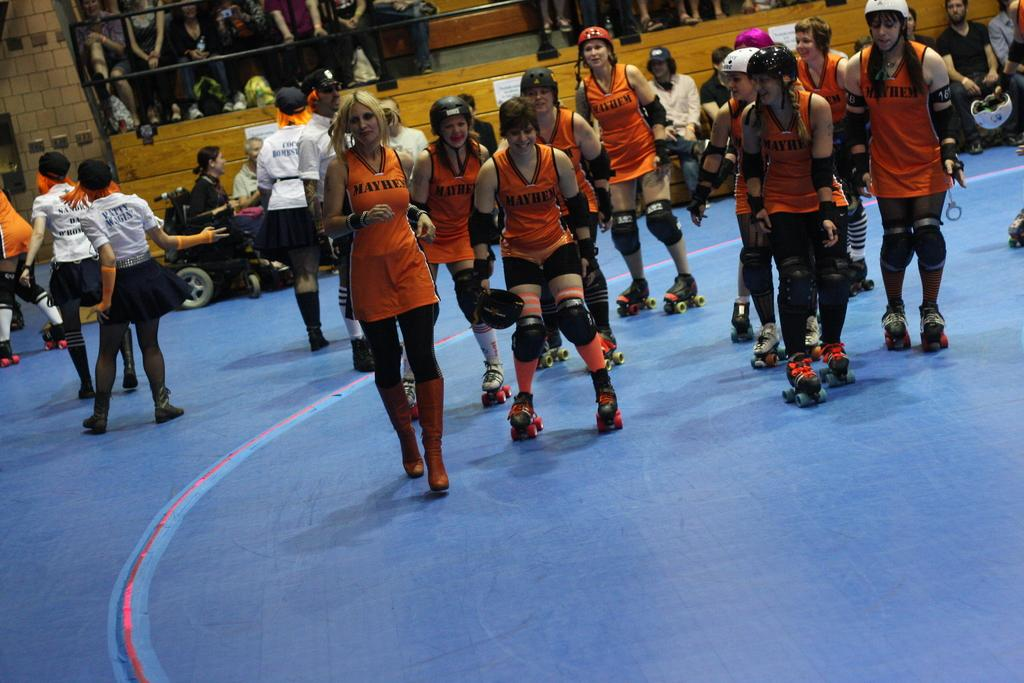How many people are in the image? There are people in the image, but the exact number is not specified. What is one person doing in the image? One person is running in the image. What are some people doing in the image? Some people are sitting in the image. What type of footwear are the people wearing? The people are wearing skating shoes. What can be seen in the background of the image? In the background, there are rods, posters on the wall, and people visible. What type of silk fabric is draped over the person's toes in the image? There is no silk fabric or reference to toes in the image; the people are wearing skating shoes. 